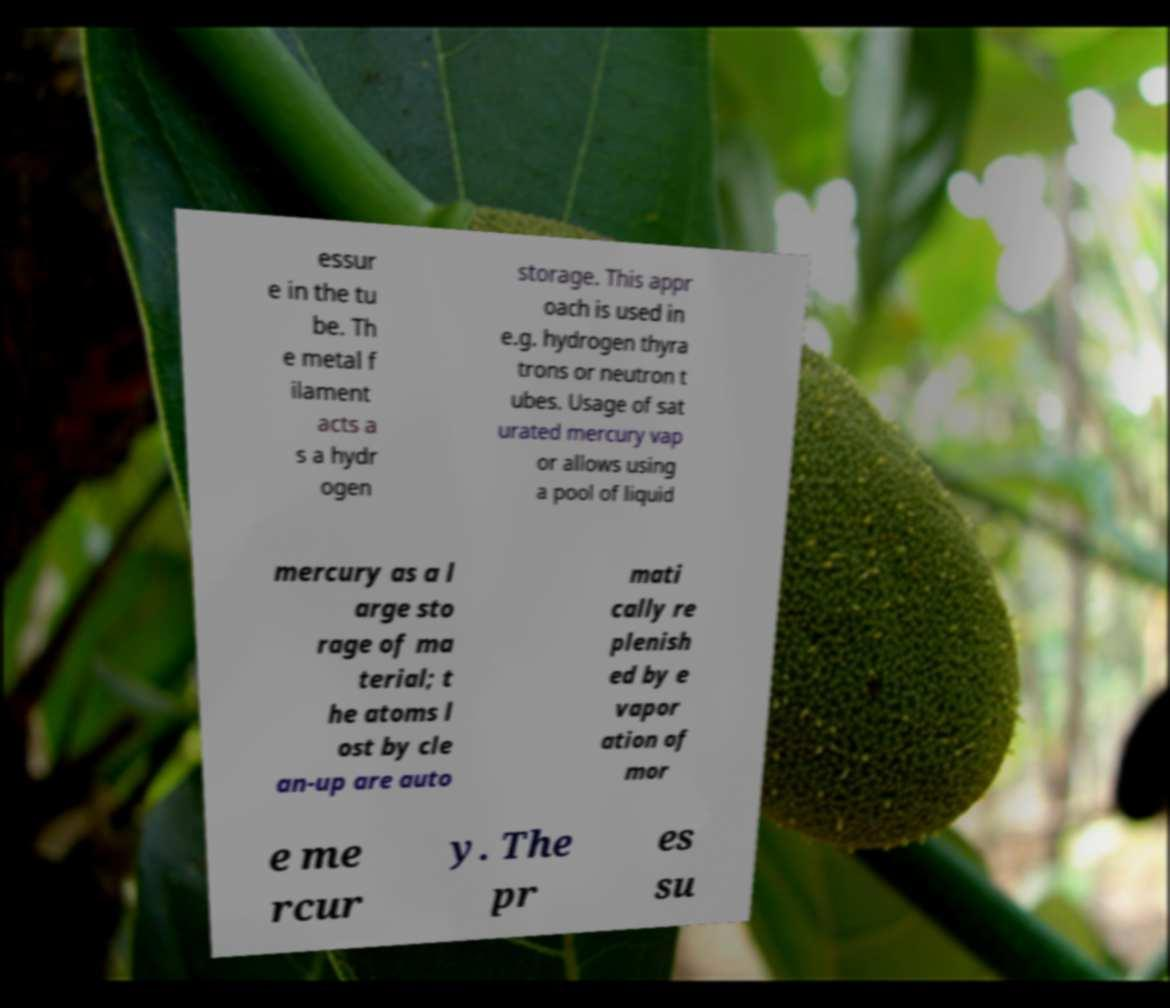Could you extract and type out the text from this image? essur e in the tu be. Th e metal f ilament acts a s a hydr ogen storage. This appr oach is used in e.g. hydrogen thyra trons or neutron t ubes. Usage of sat urated mercury vap or allows using a pool of liquid mercury as a l arge sto rage of ma terial; t he atoms l ost by cle an-up are auto mati cally re plenish ed by e vapor ation of mor e me rcur y. The pr es su 